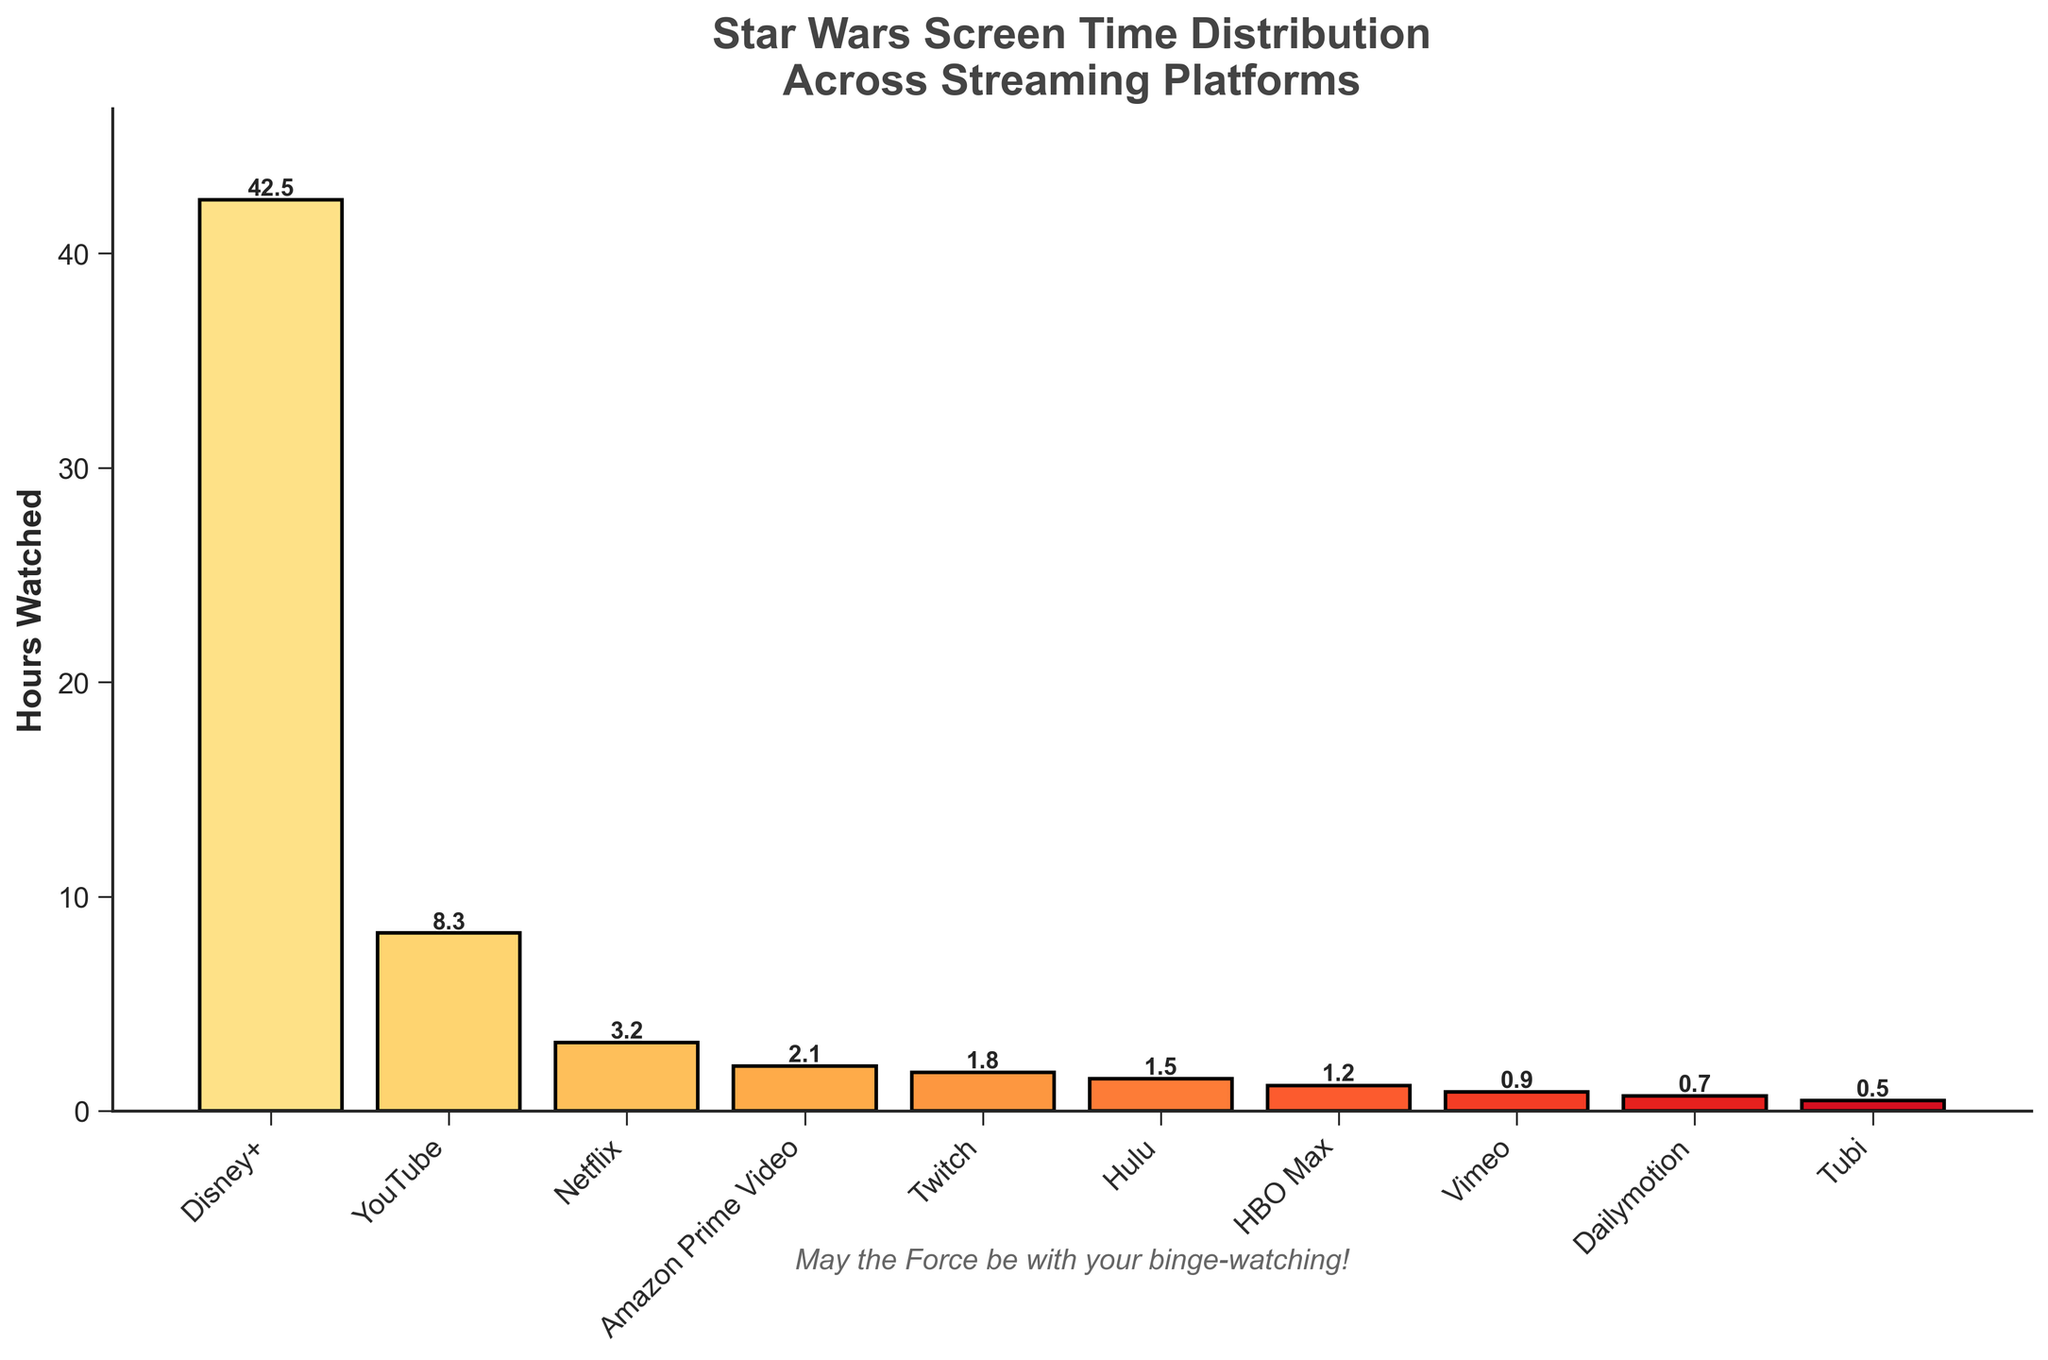What is the total screen time watched for Disney+ and Netflix combined? To get the total, add the screen time watched for Disney+ (42.5 hours) and Netflix (3.2 hours). Thus, 42.5 + 3.2 = 45.7 hours.
Answer: 45.7 hours Which platform has the least screen time watched? Look for the bar with the smallest height which represents the least amount of screen time watched. Tubi has the smallest bar at 0.5 hours.
Answer: Tubi How much more screen time does Disney+ have compared to Amazon Prime Video? Find the difference between the screen time for Disney+ and Amazon Prime Video. Disney+ has 42.5 hours and Amazon Prime Video has 2.1 hours. Therefore, 42.5 - 2.1 = 40.4 hours.
Answer: 40.4 hours What is the total screen time watched across all platforms? Sum the screen time for all the platforms listed: 42.5 (Disney+) + 8.3 (YouTube) + 3.2 (Netflix) + 2.1 (Amazon Prime Video) + 1.8 (Twitch) + 1.5 (Hulu) + 1.2 (HBO Max) + 0.9 (Vimeo) + 0.7 (Dailymotion) + 0.5 (Tubi). The total is 62.7 hours.
Answer: 62.7 hours How does the screen time for YouTube compare to that of HBO Max? Compare the height of the bars for YouTube and HBO Max. YouTube has 8.3 hours, while HBO Max has 1.2 hours. YouTube has more screen time watched than HBO Max.
Answer: YouTube has more What is the average screen time watched per platform? To find the average, divide the total screen time (62.7 hours) by the number of platforms (10). Thus, 62.7 / 10 = 6.27 hours.
Answer: 6.27 hours Which platforms have more than 1 hour of screen time watched? Identify platforms where the bar height is greater than 1 hour. These platforms are Disney+ (42.5 hours), YouTube (8.3 hours), Netflix (3.2 hours), Amazon Prime Video (2.1 hours), Twitch (1.8 hours), Hulu (1.5 hours), and HBO Max (1.2 hours).
Answer: Disney+, YouTube, Netflix, Amazon Prime Video, Twitch, Hulu, HBO Max What fraction of the total screen time is watched on Disney+? Divide the screen time for Disney+ (42.5 hours) by the total screen time for all platforms (62.7 hours). Thus, 42.5 / 62.7 ≈ 0.678.
Answer: 0.678 Which platform has the second most screen time watched? Identify the platform with the second tallest bar after Disney+. The second tallest bar belongs to YouTube with 8.3 hours.
Answer: YouTube If the screen time for Netflix doubled, where would it rank among the platforms? Double Netflix’s screen time from 3.2 hours to 6.4 hours. Compare this amount to the other platforms: 42.5 (Disney+), 8.3 (YouTube), 2.1 (Amazon Prime Video), etc. Netflix would rank third after Disney+ and YouTube.
Answer: Third 